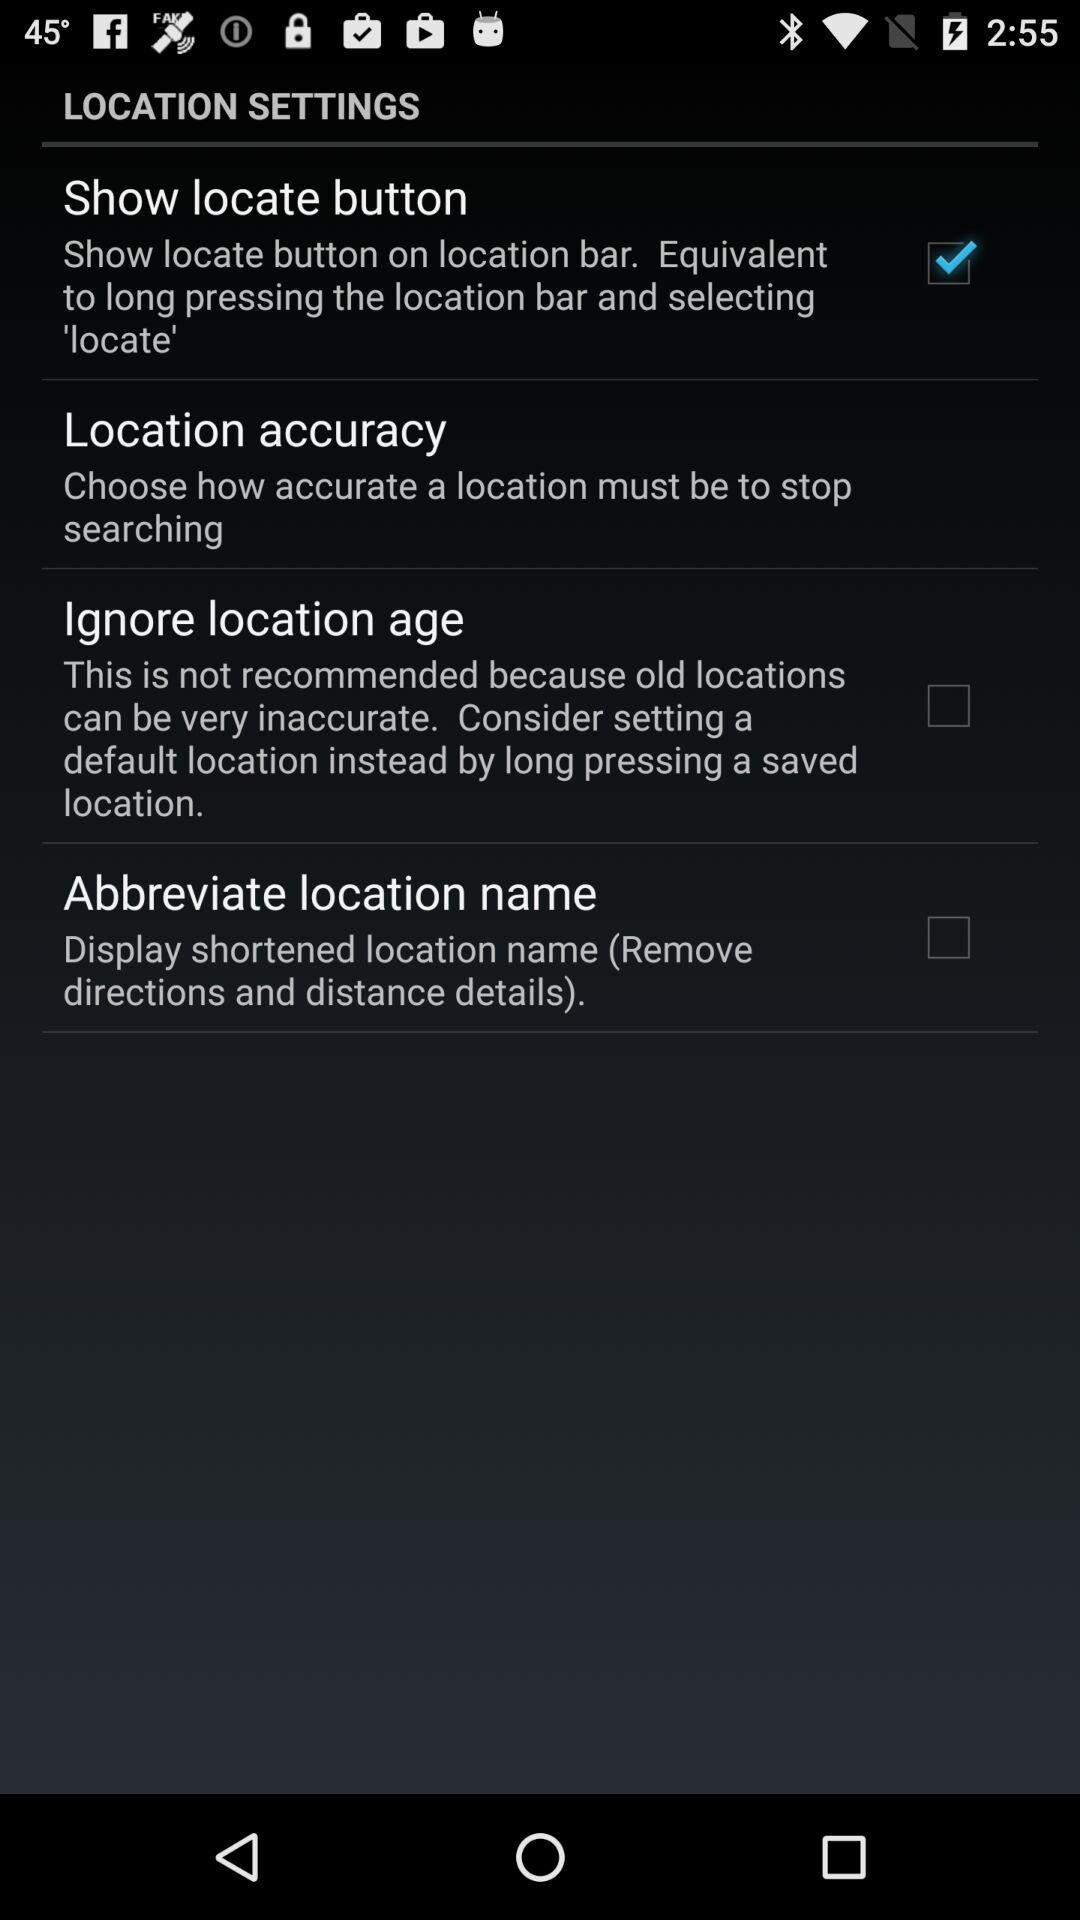What is the selected option? The selected option is "Show locate button". 